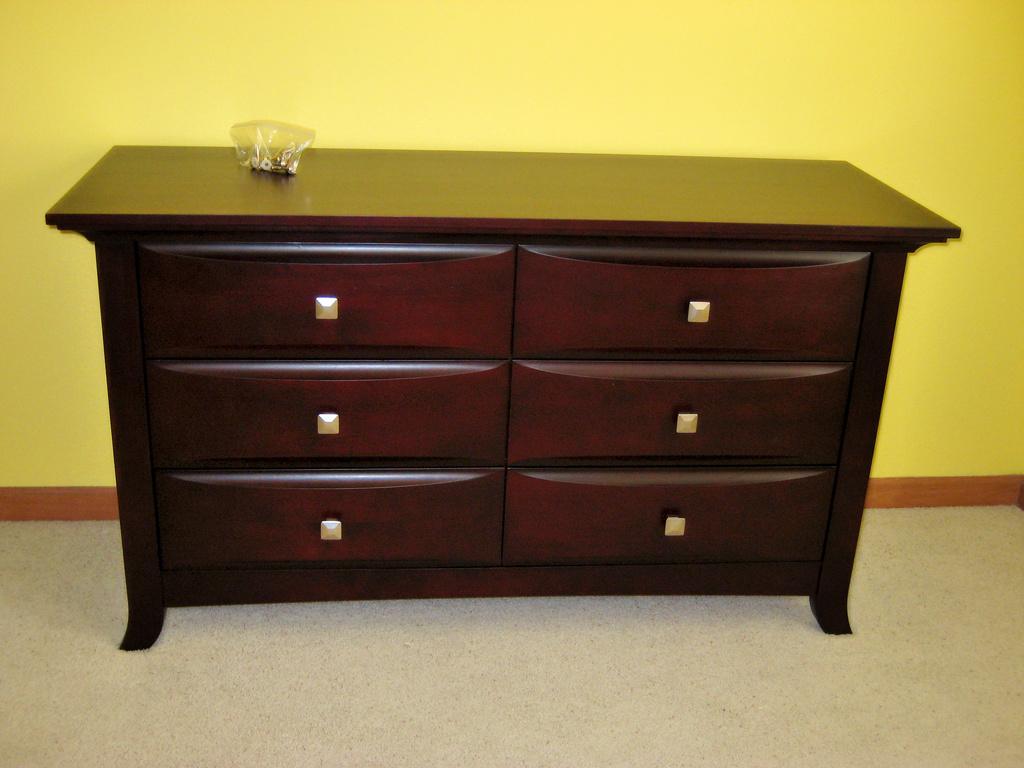In one or two sentences, can you explain what this image depicts? In this image, I can see the drawers table with an object on it. In the background, It looks like a wall, which is yellow in color. At the bottom of the image, I think this is a floor. 